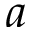<formula> <loc_0><loc_0><loc_500><loc_500>a</formula> 